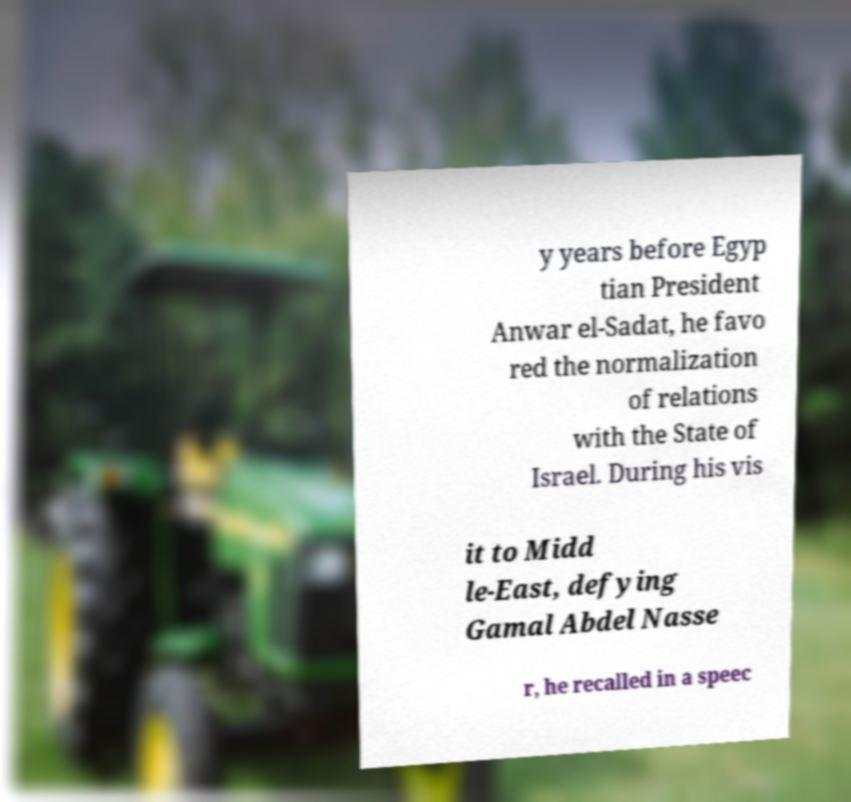For documentation purposes, I need the text within this image transcribed. Could you provide that? y years before Egyp tian President Anwar el-Sadat, he favo red the normalization of relations with the State of Israel. During his vis it to Midd le-East, defying Gamal Abdel Nasse r, he recalled in a speec 